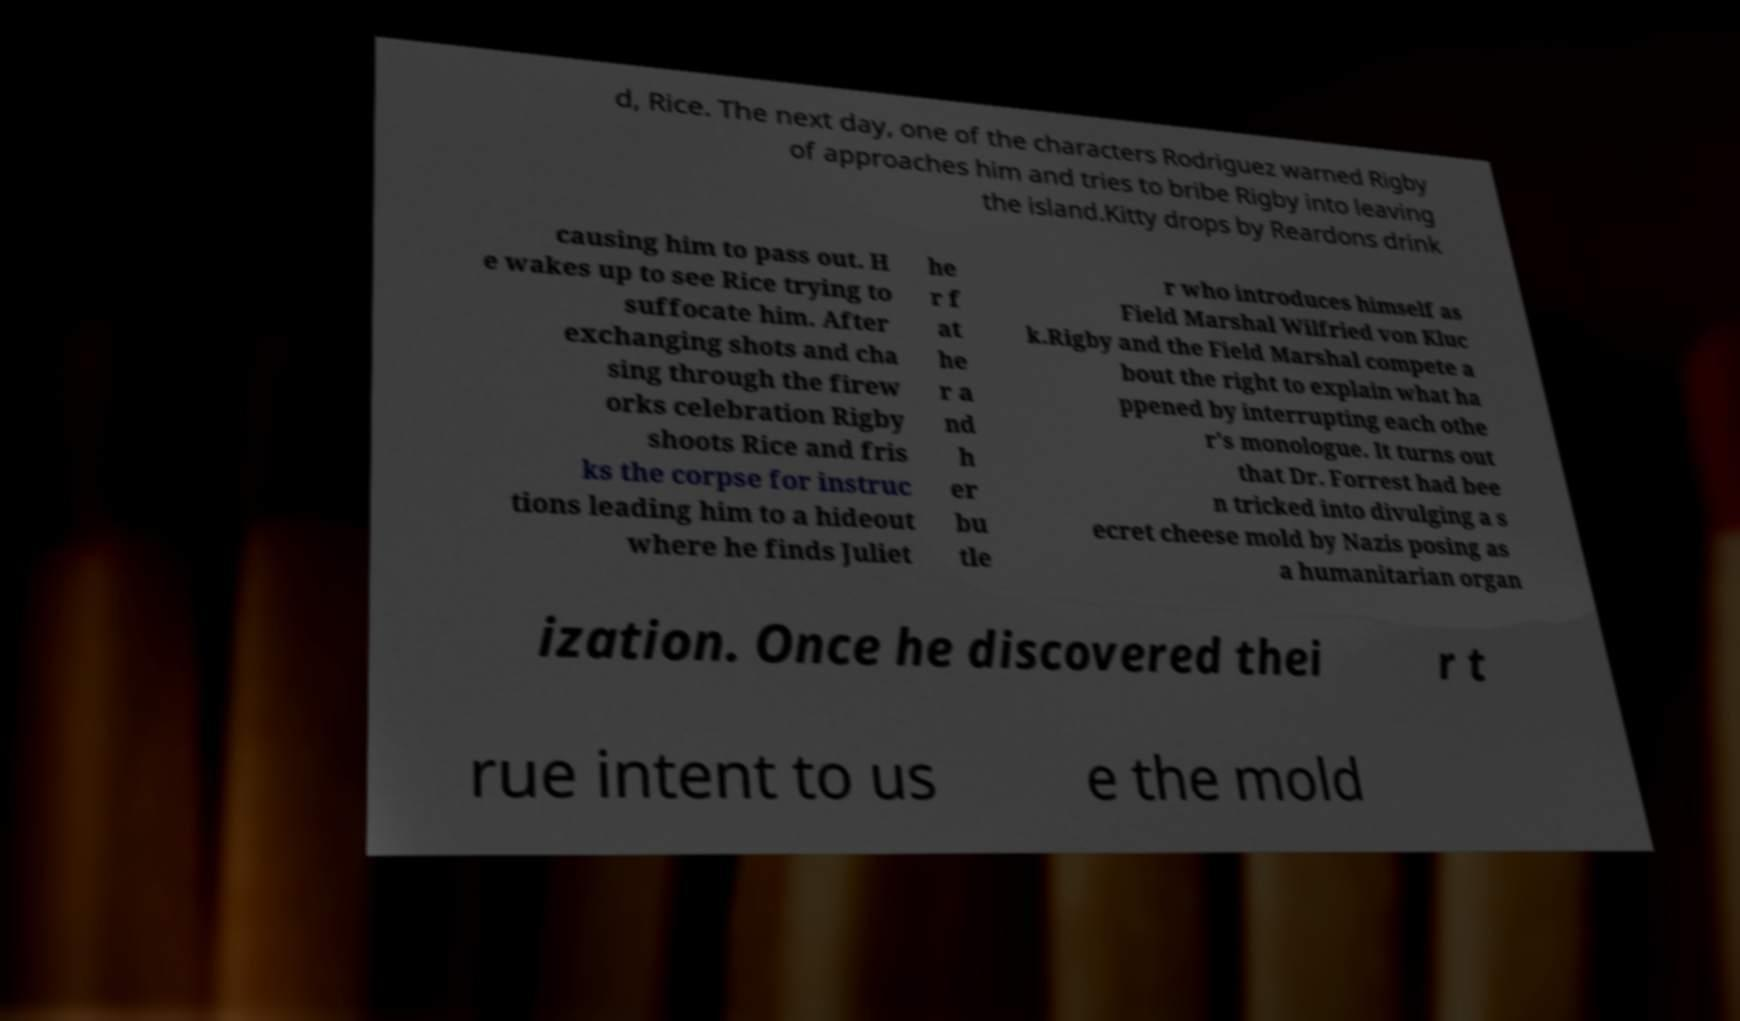What messages or text are displayed in this image? I need them in a readable, typed format. d, Rice. The next day, one of the characters Rodriguez warned Rigby of approaches him and tries to bribe Rigby into leaving the island.Kitty drops by Reardons drink causing him to pass out. H e wakes up to see Rice trying to suffocate him. After exchanging shots and cha sing through the firew orks celebration Rigby shoots Rice and fris ks the corpse for instruc tions leading him to a hideout where he finds Juliet he r f at he r a nd h er bu tle r who introduces himself as Field Marshal Wilfried von Kluc k.Rigby and the Field Marshal compete a bout the right to explain what ha ppened by interrupting each othe r's monologue. It turns out that Dr. Forrest had bee n tricked into divulging a s ecret cheese mold by Nazis posing as a humanitarian organ ization. Once he discovered thei r t rue intent to us e the mold 